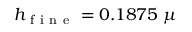<formula> <loc_0><loc_0><loc_500><loc_500>h _ { f i n e } = 0 . 1 8 7 5 \, \mu</formula> 